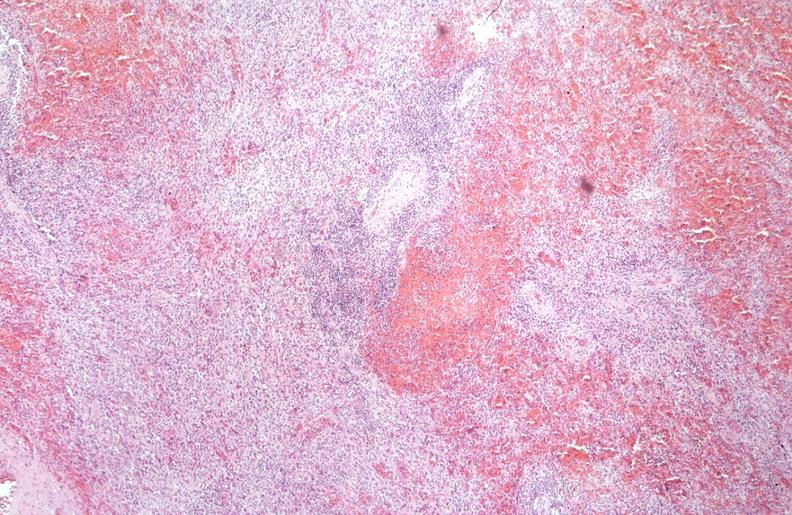what does this image show?
Answer the question using a single word or phrase. Spleen 